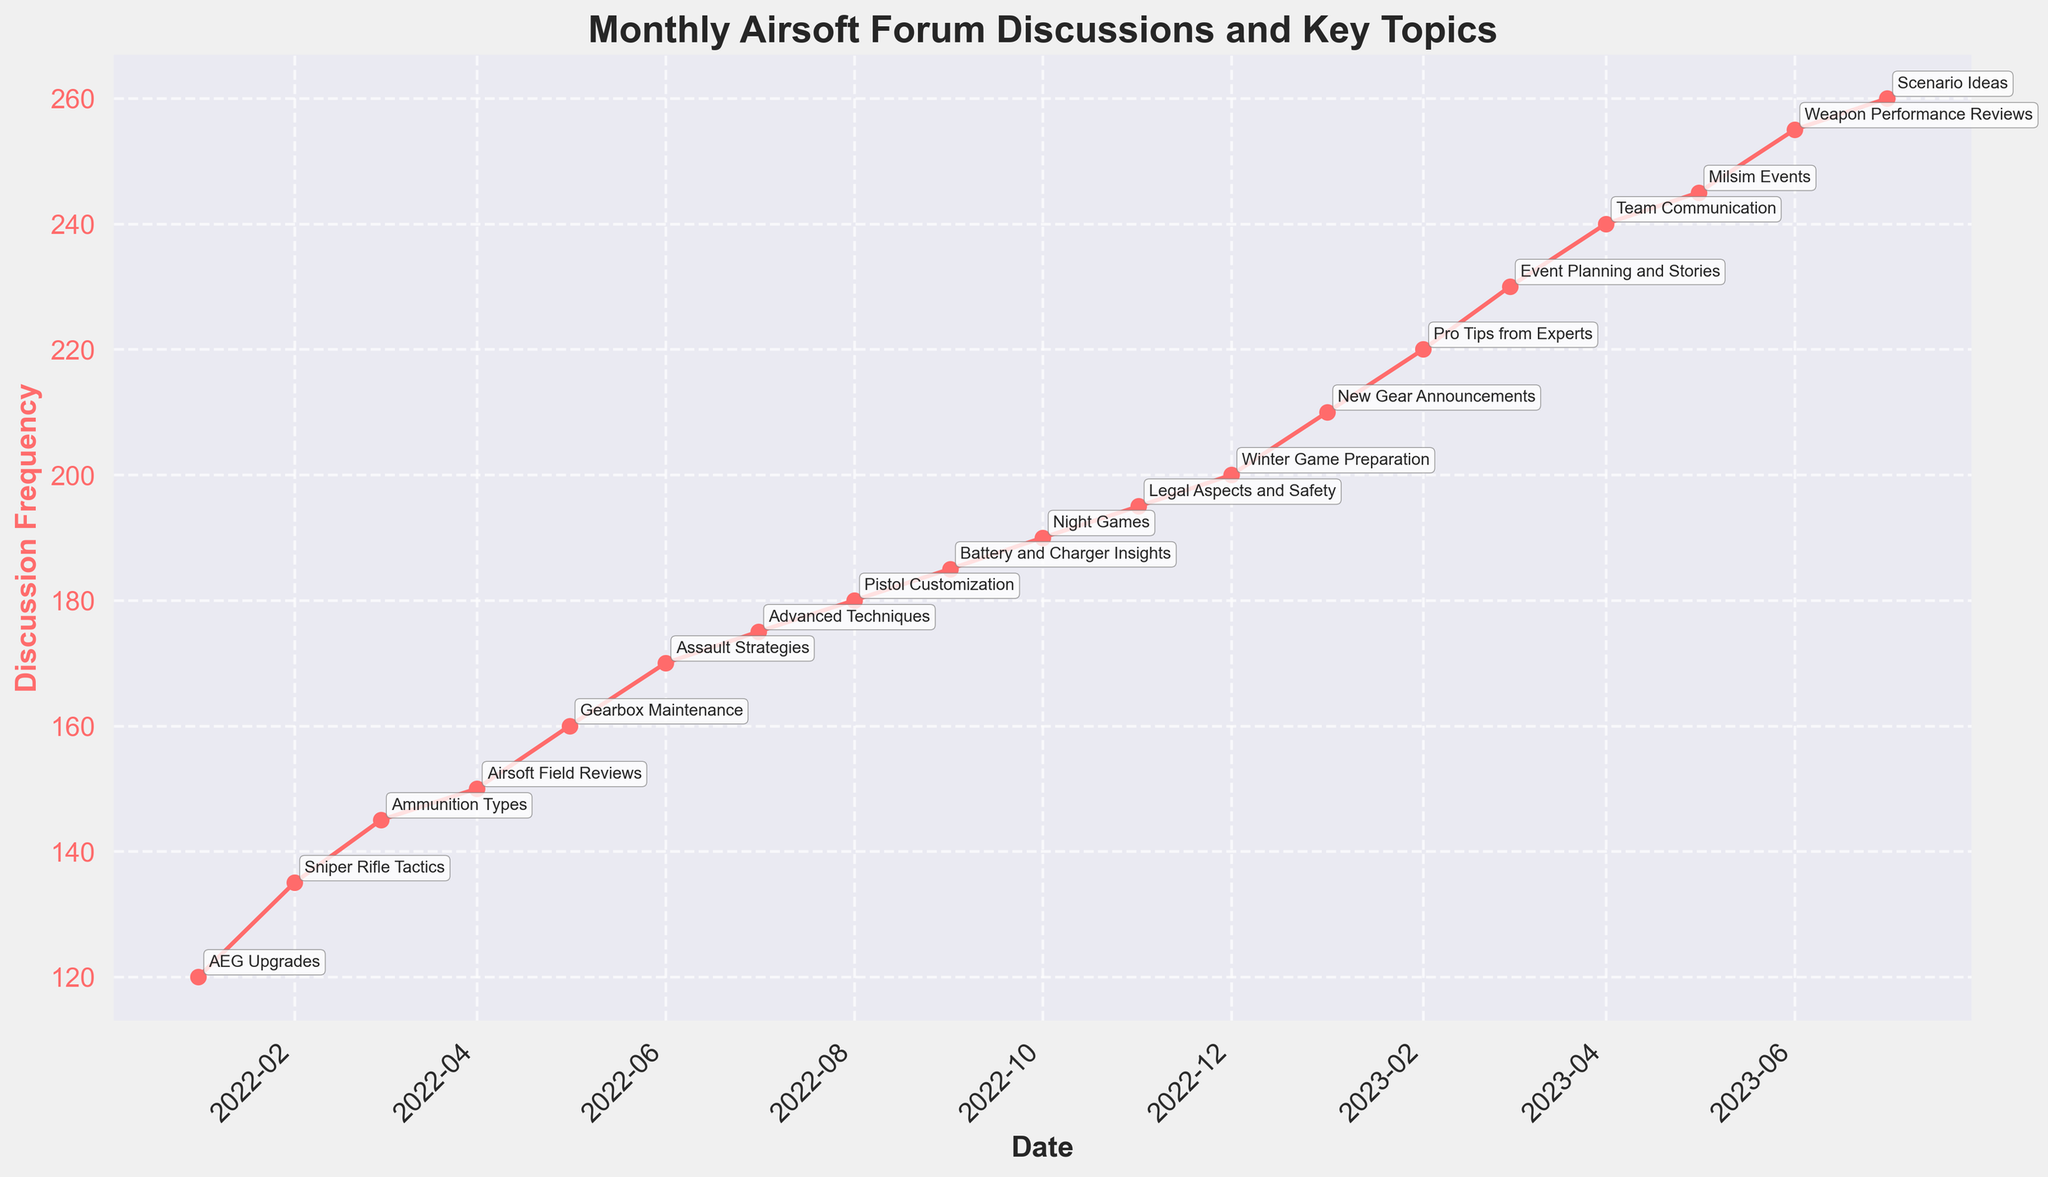What is the title of the figure? The title is shown at the top of the figure in bold. It gives a summarized idea of what the plot represents.
Answer: Monthly Airsoft Forum Discussions and Key Topics What is the highest discussion frequency observed? By inspecting the highest data point on the 'Discussion Frequency' line, we can determine the peak value.
Answer: 260 What is the key topic in January 2022? Locate the first data point for 2022-01 and read the annotation for the key topic.
Answer: AEG Upgrades Between which two months in 2022 did the discussion frequency increase the most? Compare the increase in 'Discussion Frequency' between consecutive months in 2022 by checking the differences, and find the largest increment.
Answer: May to June How many key topics are annotated in the figure? Count the number of unique annotations present alongside the data points.
Answer: 19 What is the key topic for the month with the lowest discussion frequency? Identify the month with the lowest discussion frequency, then read the associated annotation.
Answer: AEG Upgrades Are there any months where the discussion frequency decreased compared to the previous month? Scan the 'Discussion Frequency' line for any downward trends between consecutive points.
Answer: No Which key topic appears in April 2023? Locate the data point for 2023-04 and read the annotation for the key topic.
Answer: Team Communication What is the average discussion frequency over the entire period? Sum all the 'Discussion Frequency' values and divide by the total number of months to get the average. \( \frac{120 + 135 + \ldots + 260}{19} = \frac{4015}{19} \approx 211.32 \)
Answer: ~211.32 What are the months with a discussion frequency greater than 200? List all the months for which the 'Discussion Frequency' data points are above 200.
Answer: January 2023 to July 2023 